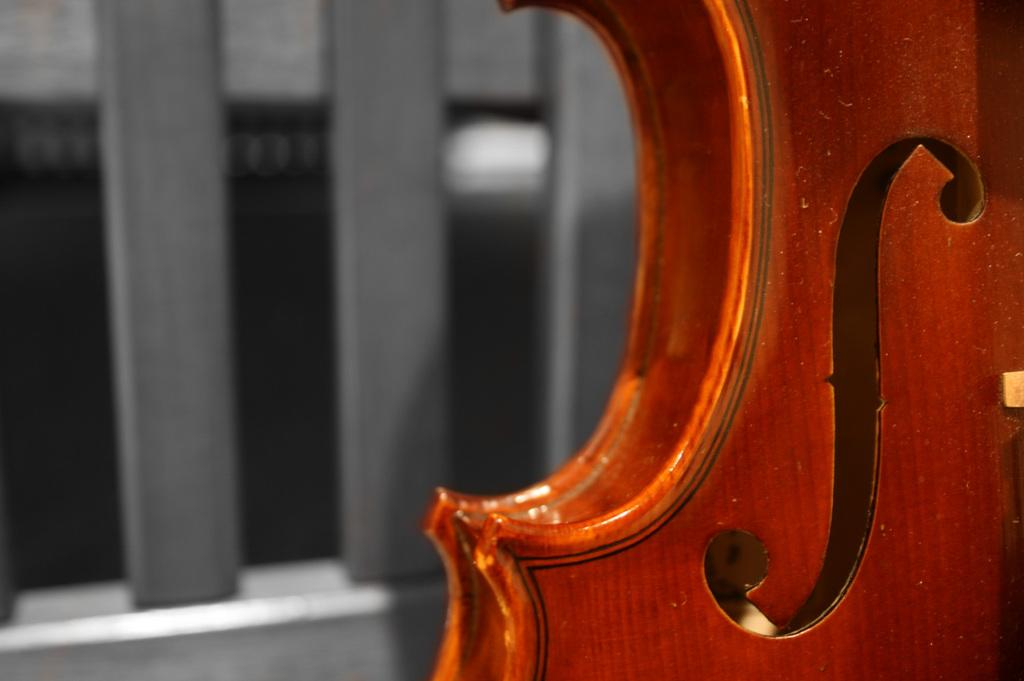What type of musical instrument is partially visible in the image? There is a part of a guitar visible in the image. Can you describe the specific part of the guitar that can be seen? Unfortunately, the provided facts do not specify which part of the guitar is visible. What might be the purpose of the guitar in the image? The guitar may be used for playing music or as a decorative element. What type of legal advice is the guitar providing in the image? The guitar is not providing legal advice, as it is a musical instrument and not a lawyer. 